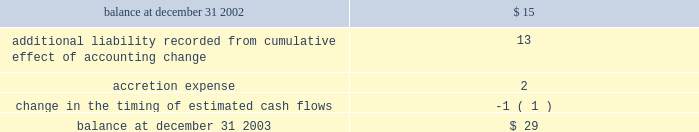Impairment of long-lived assets based on the projection of undiscounted cash flows whenever events or changes in circumstances indicate that the carrying amounts of such assets may not be recoverable .
In the event such cash flows are not expected to be sufficient to recover the recorded value of the assets , the assets are written down to their estimated fair values ( see note 5 ) .
Asset retirement obligations 2014effective january 1 , 2003 , the company adopted statement of financial accounting standards ( 2018 2018sfas 2019 2019 ) no .
143 , 2018 2018accounting for asset retirement obligations . 2019 2019 sfas no .
143 requires the company to record the fair value of a legal liability for an asset retirement obligation in the period in which it is incurred .
When a new liability is recorded the company will capitalize the costs of the liability by increasing the carrying amount of the related long-lived asset .
The liability is accreted to its present value each period and the capitalized cost is depreciated over the useful life of the related asset .
Upon settlement of the liability , the company settles the obligation for its recorded amount or incurs a gain or loss upon settlement .
The company 2019s retirement obligations covered by sfas no .
143 include primarily active ash landfills , water treatment basins and the removal or dismantlement of certain plant and equipment .
As of december 31 , 2003 and 2002 , the company had recorded liabilities of approximately $ 29 million and $ 15 million , respectively , related to asset retirement obligations .
There are no assets that are legally restricted for purposes of settling asset retirement obligations .
Upon adoption of sfas no .
143 , the company recorded an additional liability of approximately $ 13 million , a net asset of approximately $ 9 million , and a cumulative effect of a change in accounting principle of approximately $ 2 million , after income taxes .
Amounts recorded related to asset retirement obligations during the years ended december 31 , 2003 were as follows ( in millions ) : .
Proforma net ( loss ) income and ( loss ) earnings per share have not been presented for the years ended december 31 , 2002 and 2001 because the proforma application of sfas no .
143 to prior periods would result in proforma net ( loss ) income and ( loss ) earnings per share not materially different from the actual amounts reported for those periods in the accompanying consolidated statements of operations .
Had sfas 143 been applied during all periods presented the asset retirement obligation at january 1 , 2001 , december 31 , 2001 and december 31 , 2002 would have been approximately $ 21 million , $ 23 million and $ 28 million , respectively .
Included in other long-term liabilities is the accrual for the non-legal obligations for removal of assets in service at ipalco amounting to $ 361 million and $ 339 million at december 31 , 2003 and 2002 , respectively .
Deferred financing costs 2014financing costs are deferred and amortized over the related financing period using the effective interest method or the straight-line method when it does not differ materially from the effective interest method .
Deferred financing costs are shown net of accumulated amortization of $ 202 million and $ 173 million as of december 31 , 2003 and 2002 , respectively .
Project development costs 2014the company capitalizes the costs of developing new construction projects after achieving certain project-related milestones that indicate the project 2019s completion is probable .
These costs represent amounts incurred for professional services , permits , options , capitalized interest , and other costs directly related to construction .
These costs are transferred to construction in progress when significant construction activity commences , or expensed at the time the company determines that development of a particular project is no longer probable ( see note 5 ) . .
What was the difference in millions in liabilities related to asset retirement obligations between 2003 and 2003? 
Computations: (29 - 15)
Answer: 14.0. 